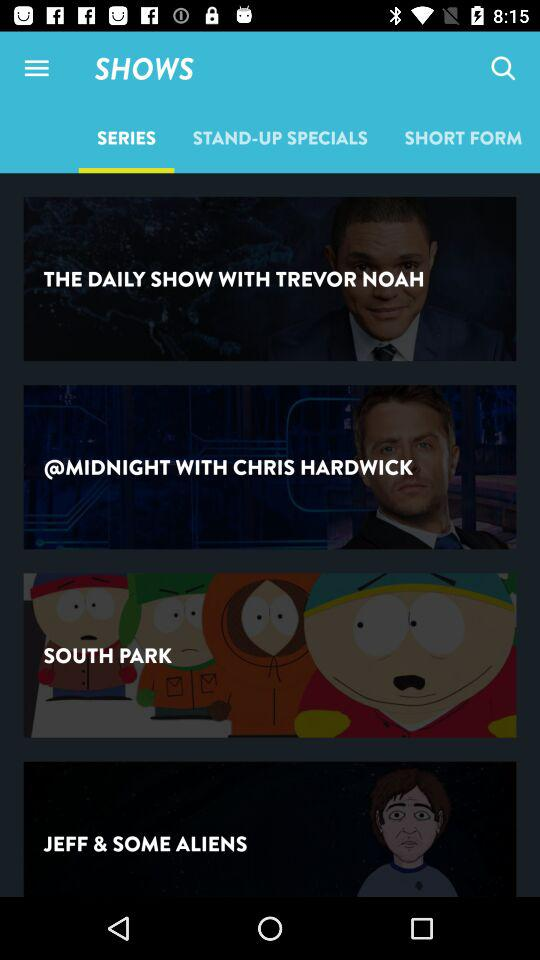Which comedians have stand-up specials?
When the provided information is insufficient, respond with <no answer>. <no answer> 